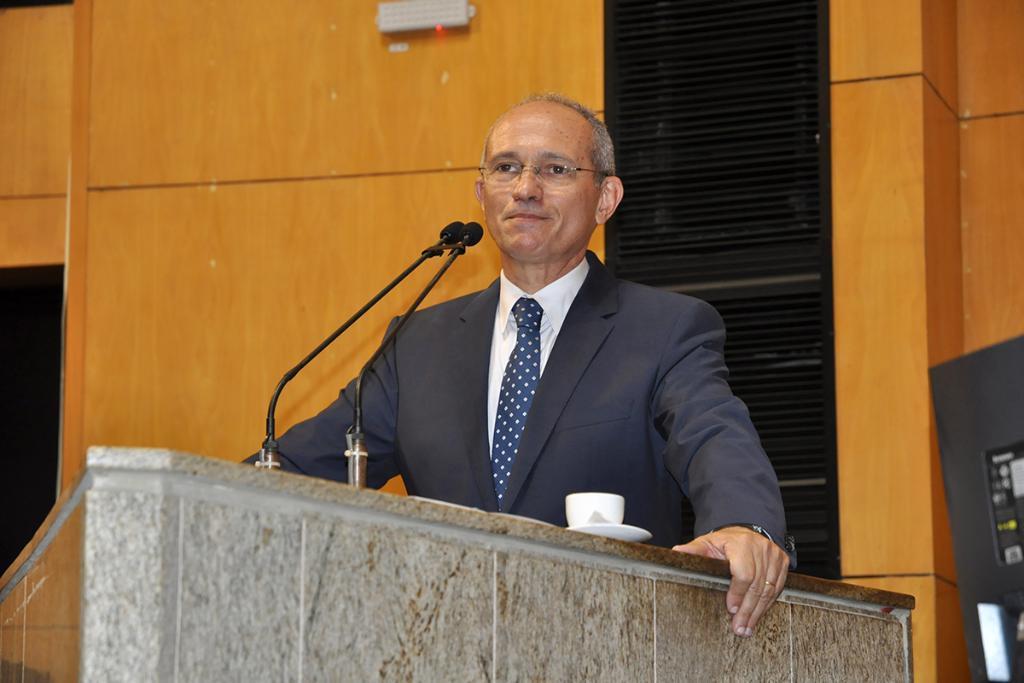Please provide a concise description of this image. This man is highlighted in this picture. He wore spectacles and suit. In-front of this man there is a podium with mic. Above the podium there is a cup and saucer. Background it is in orange and black color. 